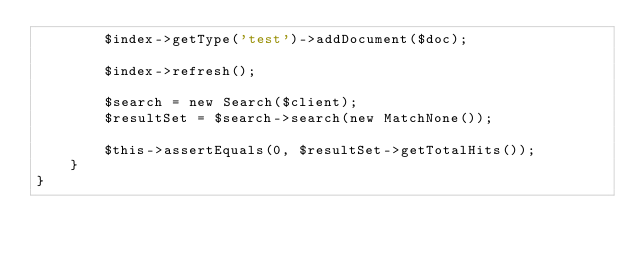Convert code to text. <code><loc_0><loc_0><loc_500><loc_500><_PHP_>        $index->getType('test')->addDocument($doc);

        $index->refresh();

        $search = new Search($client);
        $resultSet = $search->search(new MatchNone());

        $this->assertEquals(0, $resultSet->getTotalHits());
    }
}
</code> 